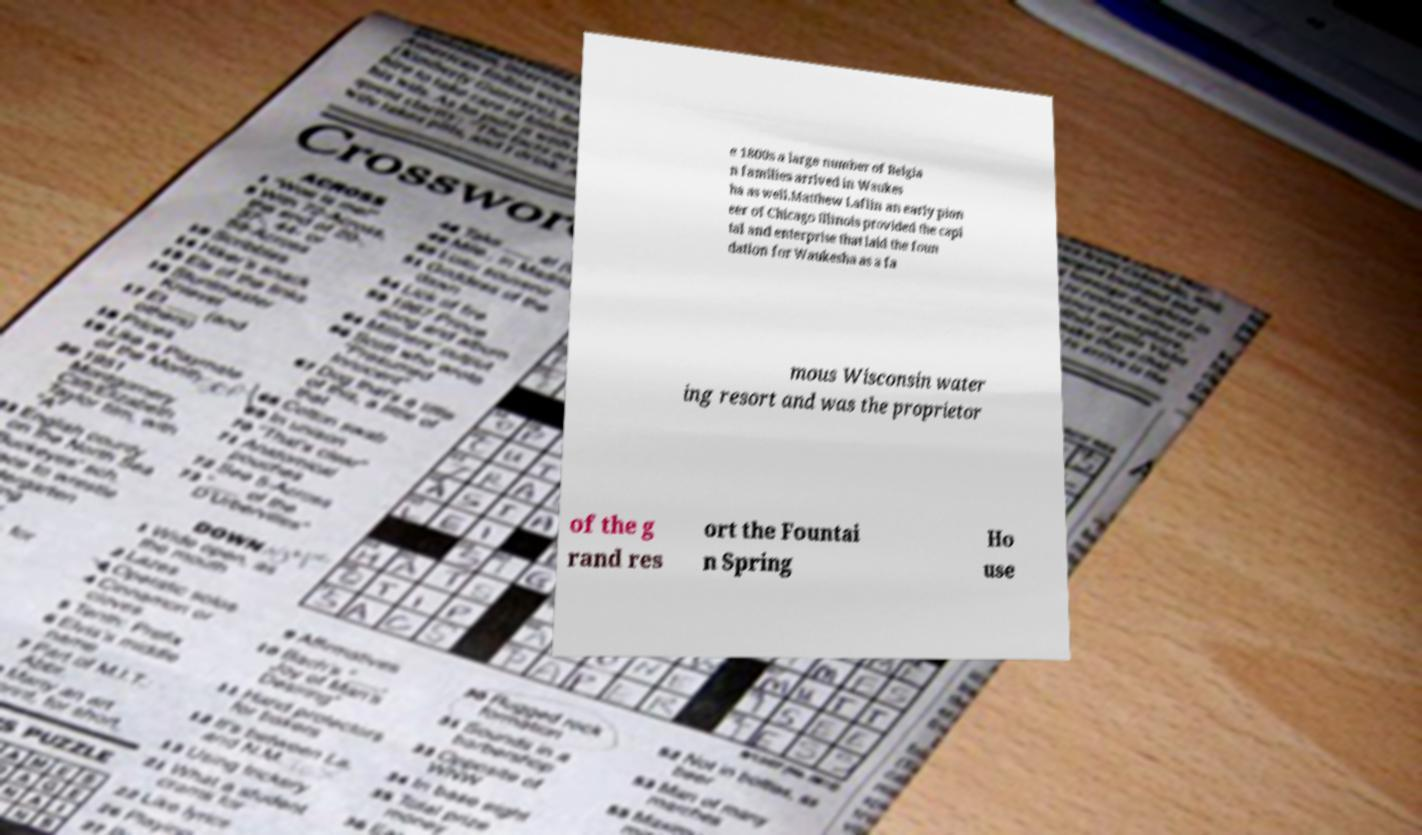I need the written content from this picture converted into text. Can you do that? e 1800s a large number of Belgia n families arrived in Waukes ha as well.Matthew Laflin an early pion eer of Chicago Illinois provided the capi tal and enterprise that laid the foun dation for Waukesha as a fa mous Wisconsin water ing resort and was the proprietor of the g rand res ort the Fountai n Spring Ho use 